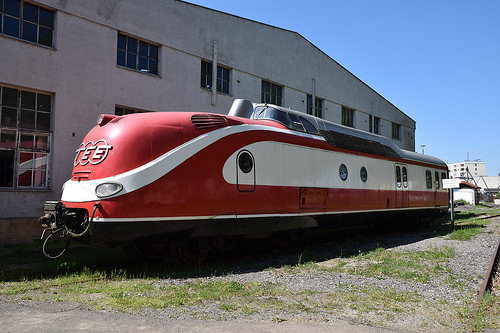<image>
Can you confirm if the building is in the train? No. The building is not contained within the train. These objects have a different spatial relationship. Is the building in front of the train? No. The building is not in front of the train. The spatial positioning shows a different relationship between these objects. 